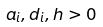Convert formula to latex. <formula><loc_0><loc_0><loc_500><loc_500>a _ { i } , d _ { i } , h > 0</formula> 